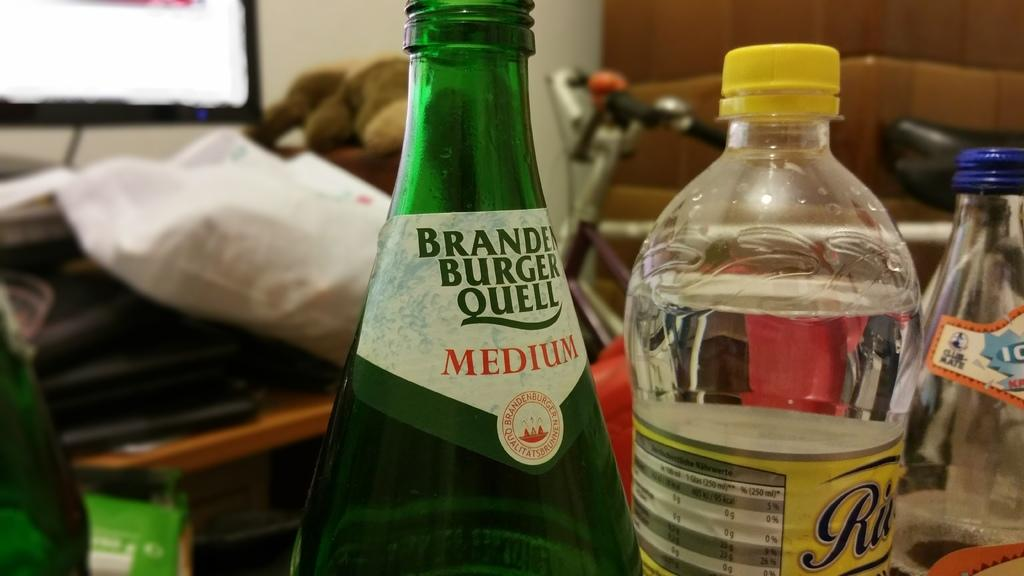What objects can be seen in the image? There are bottles in the image. What can be seen in the background of the image? There is a cycle and a screen in the background of the image. Where is the toad sitting in the image? There is no toad present in the image. What type of desk can be seen in the image? There is no desk present in the image. 